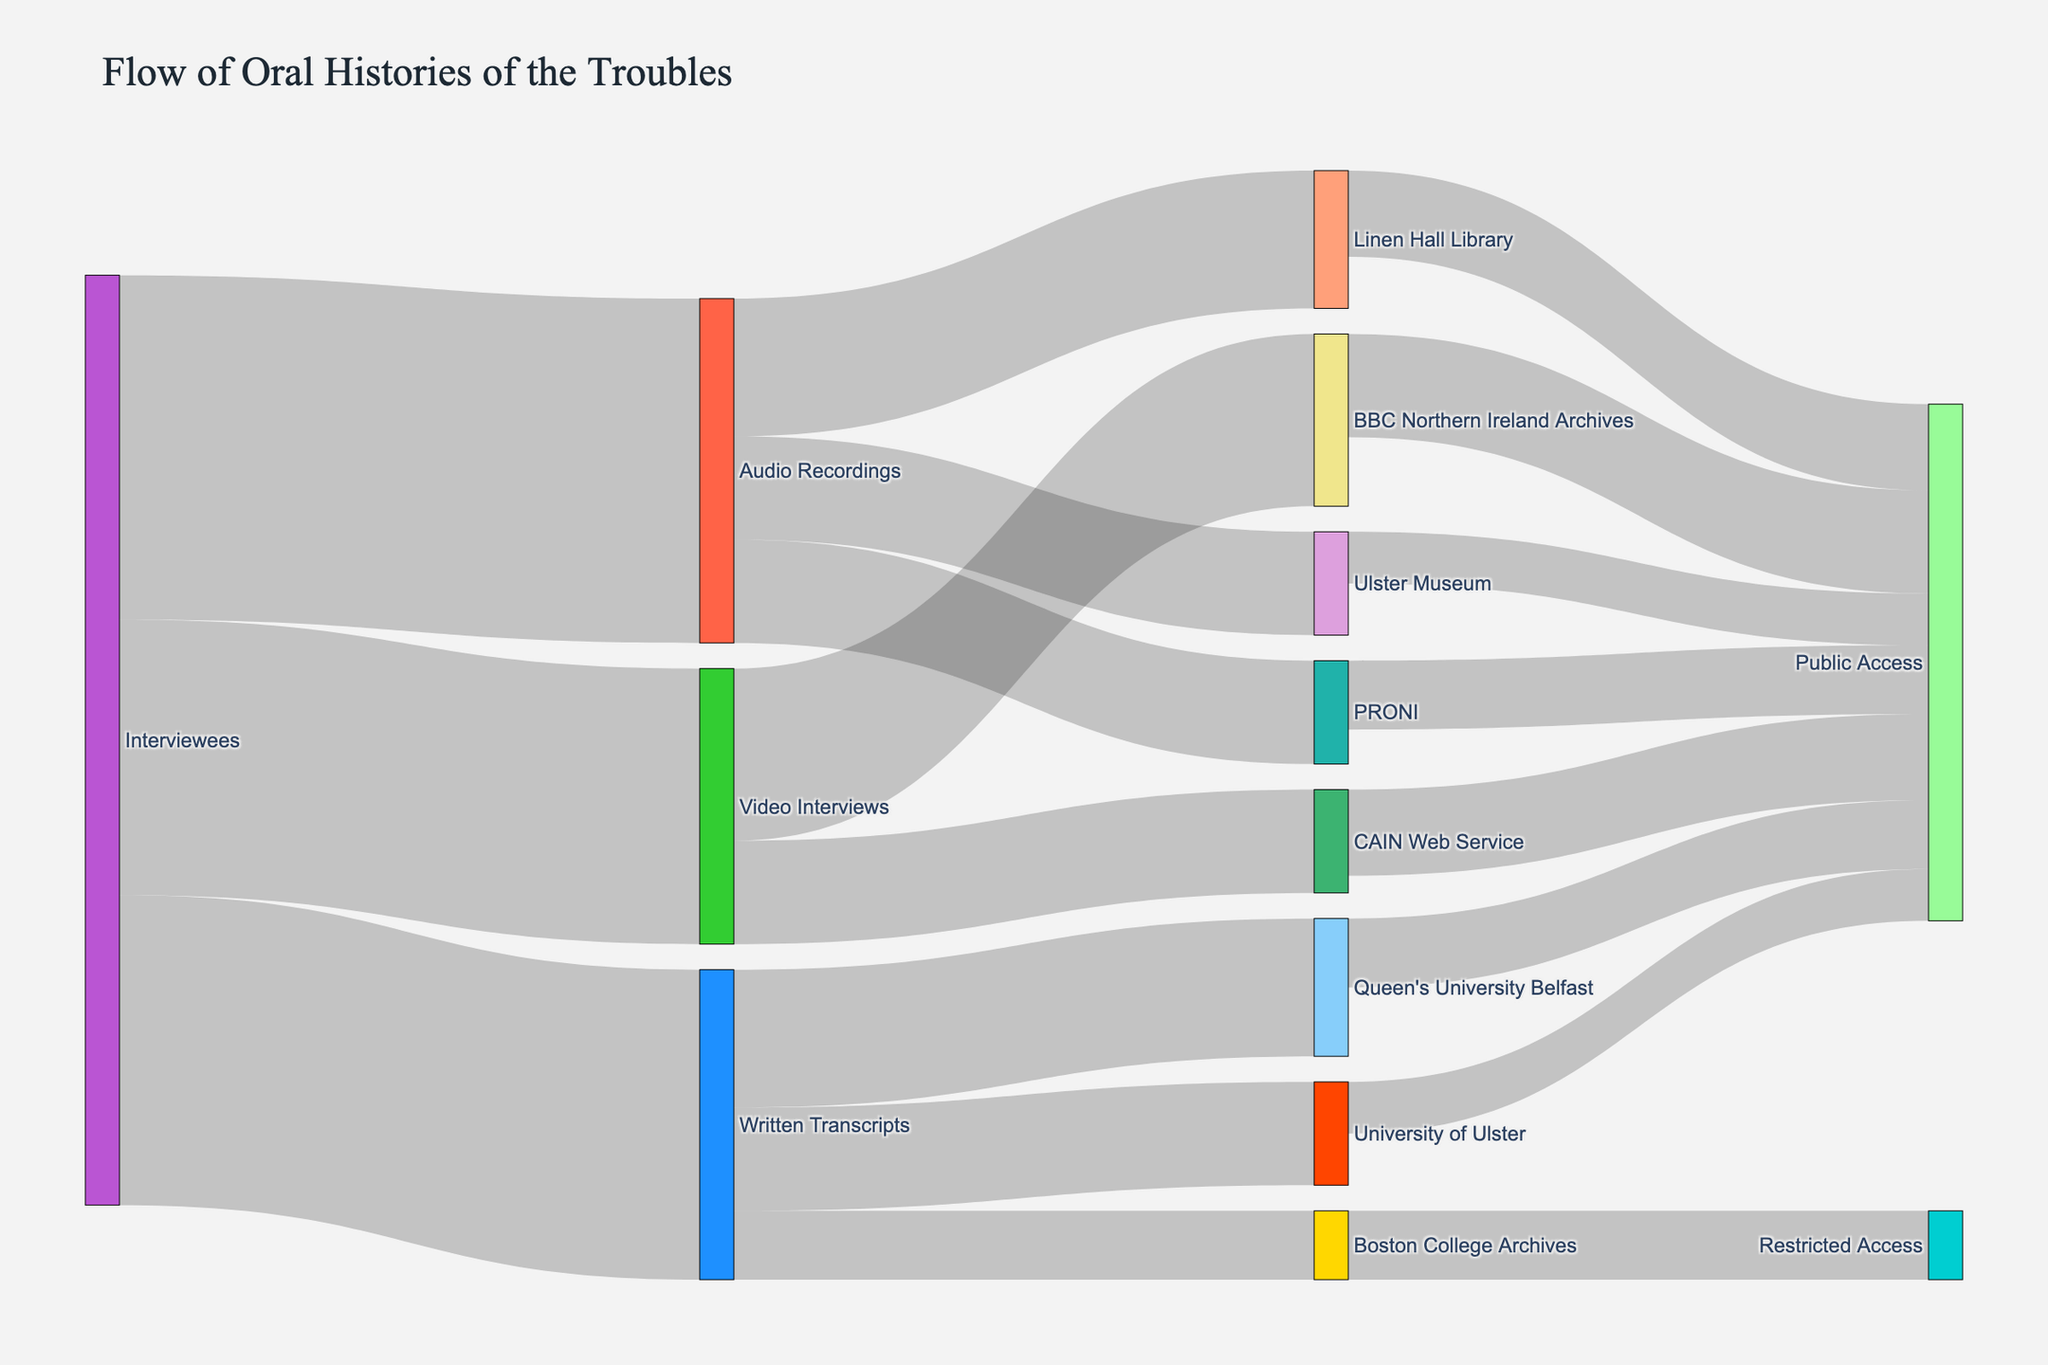How many interviewees provided audio recordings? The flow from "Interviewees" to "Audio Recordings" denotes the number of such contributions. Referring to the diagram, this flow is labeled with "100".
Answer: 100 Which archival format received the most contributions from interviewees? From the diagram, compare the values of the flows from "Interviewees" to each archival format: "Audio Recordings" (100), "Video Interviews" (80), "Written Transcripts" (90). The highest value is "Audio Recordings".
Answer: Audio Recordings What's the total number of contributions received by PRONI? PRONI receives contributions from "Audio Recordings", verified by following the link labeled "30". Additionally, "Restricted/Public Access" links to PRONI don't affect it directly. Hence, PRONI received 30 contributions.
Answer: 30 Which public access channel has the highest contributions? Summing contributions leading to each public access channel: "Public Access" linked from "Linen Hall Library" (25), "PRONI" (20), "Ulster Museum" (15), "BBC Northern Ireland Archives" (30), and "CAIN Web Service" (25). The highest value is the BBC Northern Ireland Archives with 30.
Answer: BBC Northern Ireland Archives How many audio recordings were archived at Ulster Museum? Following the flow from "Audio Recordings" to "Ulster Museum", it is labeled with "30". Thus, Ulster Museum received 30 audio recordings.
Answer: 30 What's the total number of contributions to public access channels? Totaling contributions to "Public Access" from all sources: Linen Hall Library (25), PRONI (20), Ulster Museum (15), BBC Northern Ireland Archives (30), CAIN Web Service (25), Queen's University Belfast (20), University of Ulster (15). The sum is 150.
Answer: 150 Which archival format provided the least number of materials to public access channels? Summing contributions to public access channels from each archival format:
Audio Recordings: 40 + 30 + 30 = 100,
Video Interviews: 50 + 30 = 80,
Written Transcripts: 40 + 30 = 70.
The least sum is from Written Transcripts with 70.
Answer: Written Transcripts How many contributions from interviewees were converted into video interviews and later archived? Review how interviewee contributions flow into "Video Interviews" (80) and further to archival targets "BBC Northern Ireland Archives" (50) and "CAIN Web Service" (30). Totalling equals 80.
Answer: 80 